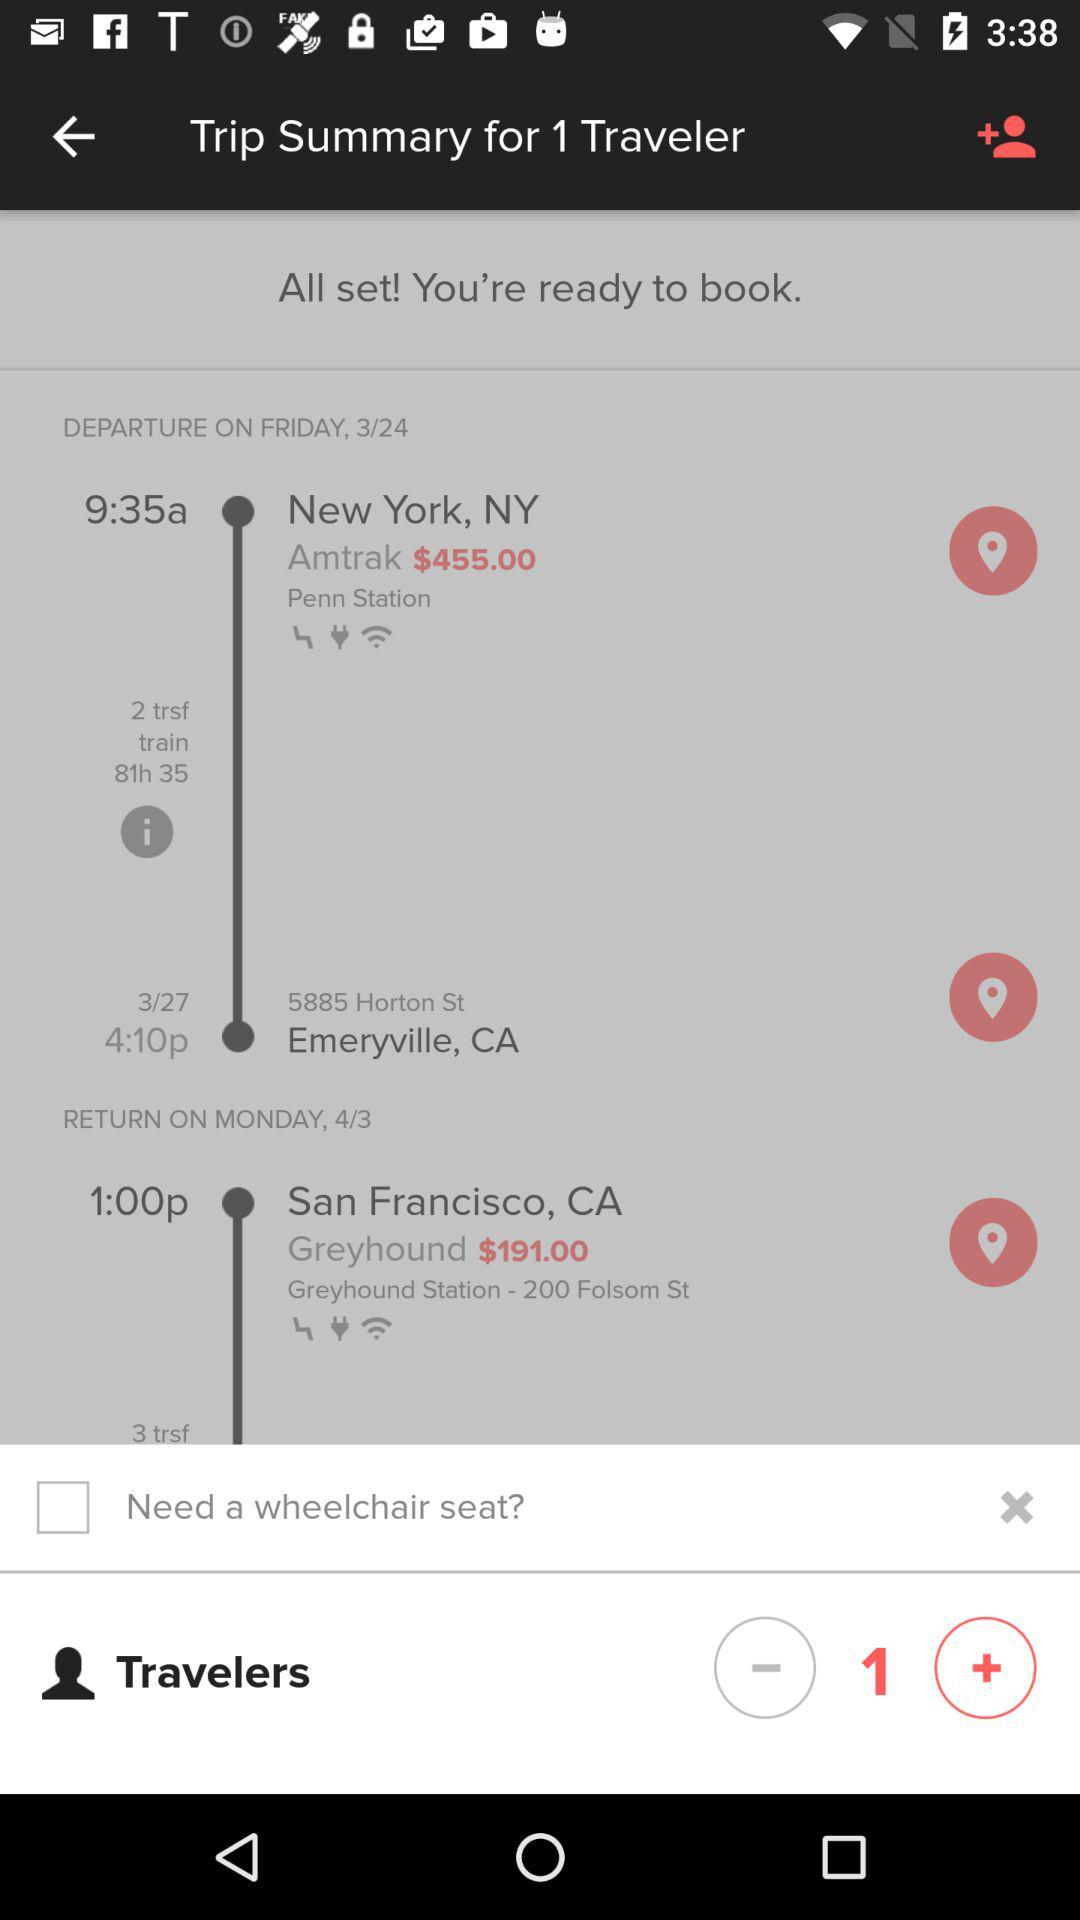How many people are travelling? There is 1 person travelling. 